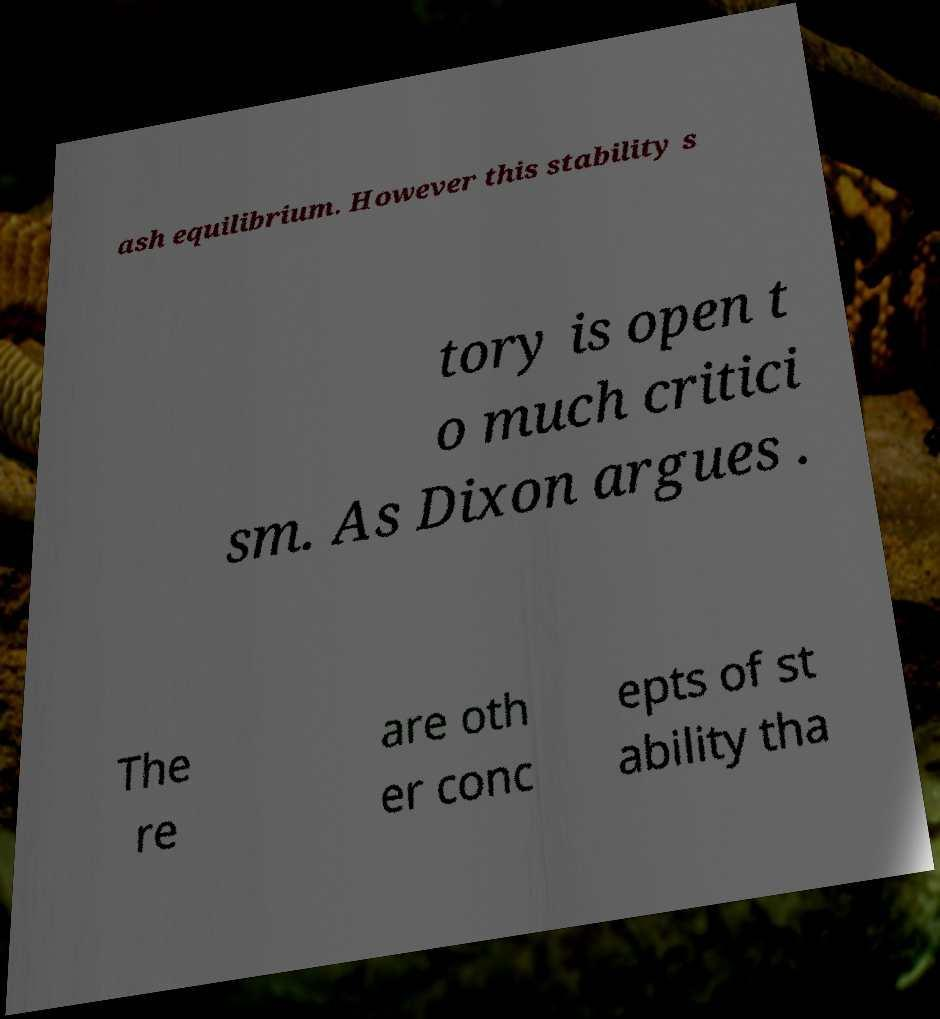Can you read and provide the text displayed in the image?This photo seems to have some interesting text. Can you extract and type it out for me? ash equilibrium. However this stability s tory is open t o much critici sm. As Dixon argues . The re are oth er conc epts of st ability tha 